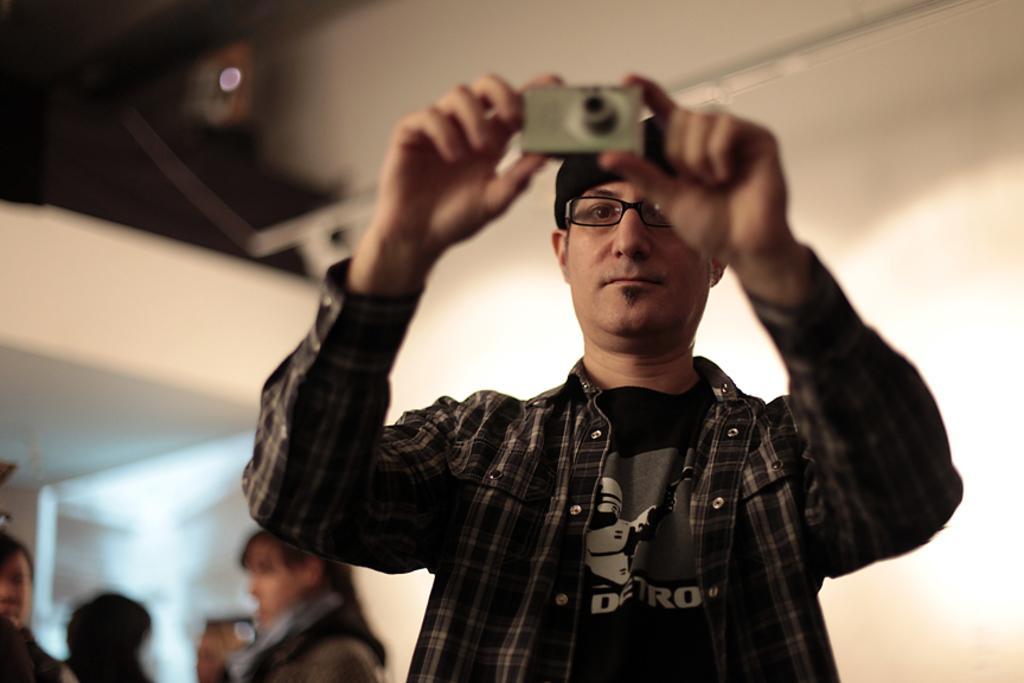In one or two sentences, can you explain what this image depicts? In this image there is a man standing and taking a picture with a camera and the back ground there are group of people standing. 